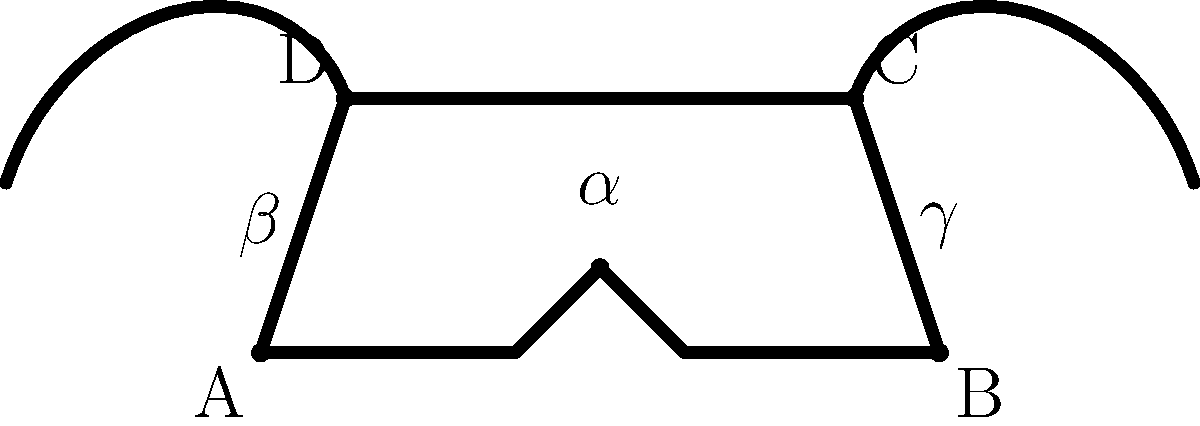In your latest artistic interpretation of a longhorn skull, you've stylized it with specific angles and proportions. The skull's base width (AB) is 160 units, and its height (from the base to the top of the skull) is 60 units. The angle at the top of the skull (α) is 120°. If the angles β and γ are equal, what is the measure of angle β in degrees? Let's approach this step-by-step:

1) First, we need to recognize that the sum of angles in a quadrilateral is always 360°.

2) In this quadrilateral ABCD, we know one angle (α) is 120°.

3) We're told that angles β and γ are equal. Let's call the measure of each of these angles x°.

4) The fourth angle of the quadrilateral (at point B) is a right angle (90°) due to the perpendicular nature of the base and side of the skull.

5) We can now set up an equation:
   
   $$120° + x° + x° + 90° = 360°$$

6) Simplify:
   
   $$120° + 2x° + 90° = 360°$$

7) Combine like terms:
   
   $$210° + 2x° = 360°$$

8) Subtract 210° from both sides:
   
   $$2x° = 150°$$

9) Divide both sides by 2:
   
   $$x° = 75°$$

Therefore, the measure of angle β is 75°.
Answer: 75° 